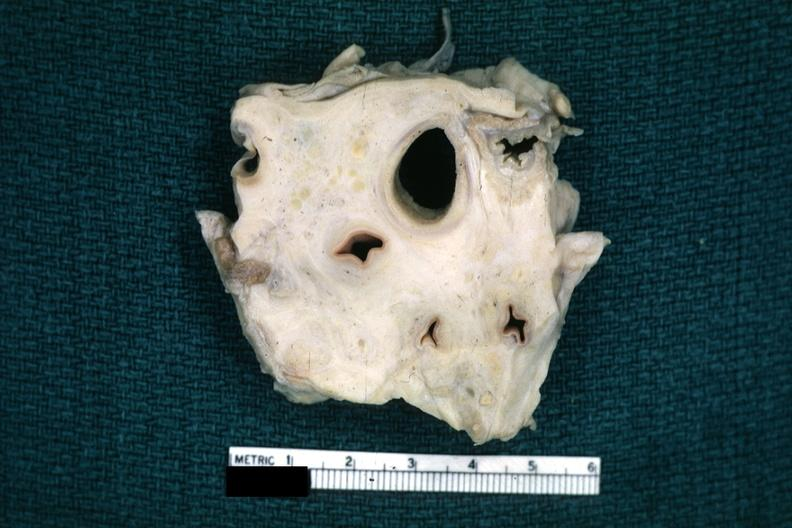s aorta present?
Answer the question using a single word or phrase. No 